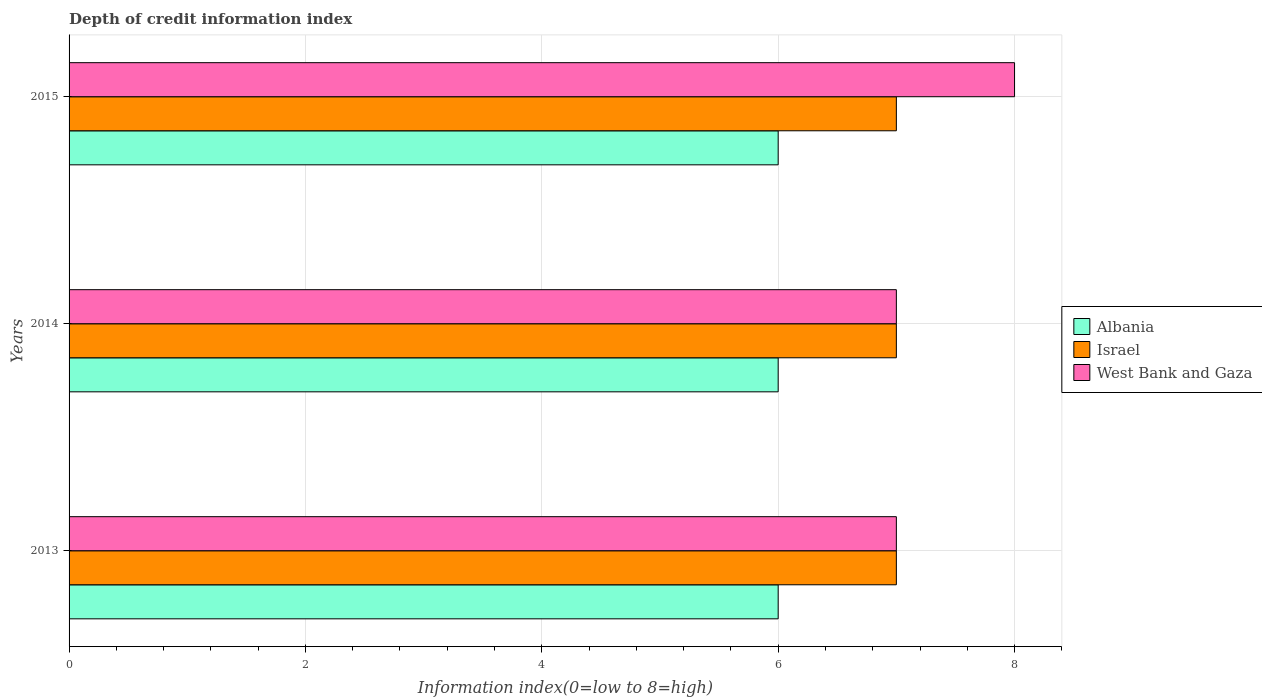How many groups of bars are there?
Provide a succinct answer. 3. Are the number of bars on each tick of the Y-axis equal?
Your answer should be very brief. Yes. How many bars are there on the 2nd tick from the top?
Offer a terse response. 3. How many bars are there on the 3rd tick from the bottom?
Provide a short and direct response. 3. What is the label of the 3rd group of bars from the top?
Ensure brevity in your answer.  2013. In how many cases, is the number of bars for a given year not equal to the number of legend labels?
Your answer should be compact. 0. What is the information index in West Bank and Gaza in 2013?
Ensure brevity in your answer.  7. Across all years, what is the minimum information index in Israel?
Ensure brevity in your answer.  7. In which year was the information index in West Bank and Gaza maximum?
Provide a short and direct response. 2015. In which year was the information index in West Bank and Gaza minimum?
Provide a short and direct response. 2013. What is the total information index in Israel in the graph?
Give a very brief answer. 21. What is the difference between the information index in Israel in 2013 and that in 2014?
Your answer should be very brief. 0. What is the difference between the information index in Israel in 2014 and the information index in West Bank and Gaza in 2015?
Offer a very short reply. -1. In the year 2015, what is the difference between the information index in Albania and information index in Israel?
Offer a terse response. -1. In how many years, is the information index in Israel greater than 7.2 ?
Offer a very short reply. 0. Is the information index in Israel in 2013 less than that in 2015?
Give a very brief answer. No. What is the difference between the highest and the second highest information index in West Bank and Gaza?
Give a very brief answer. 1. What is the difference between the highest and the lowest information index in West Bank and Gaza?
Your response must be concise. 1. Is the sum of the information index in Albania in 2013 and 2014 greater than the maximum information index in Israel across all years?
Your answer should be compact. Yes. What does the 1st bar from the top in 2014 represents?
Ensure brevity in your answer.  West Bank and Gaza. Are all the bars in the graph horizontal?
Keep it short and to the point. Yes. How many years are there in the graph?
Offer a very short reply. 3. What is the difference between two consecutive major ticks on the X-axis?
Ensure brevity in your answer.  2. Does the graph contain grids?
Your response must be concise. Yes. How are the legend labels stacked?
Provide a succinct answer. Vertical. What is the title of the graph?
Your response must be concise. Depth of credit information index. Does "Croatia" appear as one of the legend labels in the graph?
Offer a terse response. No. What is the label or title of the X-axis?
Your answer should be compact. Information index(0=low to 8=high). What is the label or title of the Y-axis?
Offer a very short reply. Years. What is the Information index(0=low to 8=high) of Albania in 2013?
Your answer should be very brief. 6. What is the Information index(0=low to 8=high) in Albania in 2014?
Ensure brevity in your answer.  6. What is the Information index(0=low to 8=high) of Israel in 2014?
Offer a terse response. 7. What is the Information index(0=low to 8=high) of Albania in 2015?
Make the answer very short. 6. What is the Information index(0=low to 8=high) of West Bank and Gaza in 2015?
Make the answer very short. 8. Across all years, what is the minimum Information index(0=low to 8=high) of West Bank and Gaza?
Offer a very short reply. 7. What is the total Information index(0=low to 8=high) in Israel in the graph?
Your answer should be very brief. 21. What is the difference between the Information index(0=low to 8=high) of Israel in 2013 and that in 2014?
Provide a succinct answer. 0. What is the difference between the Information index(0=low to 8=high) in West Bank and Gaza in 2013 and that in 2014?
Keep it short and to the point. 0. What is the difference between the Information index(0=low to 8=high) of West Bank and Gaza in 2013 and that in 2015?
Your answer should be compact. -1. What is the difference between the Information index(0=low to 8=high) of Albania in 2013 and the Information index(0=low to 8=high) of Israel in 2014?
Provide a succinct answer. -1. What is the difference between the Information index(0=low to 8=high) in Albania in 2013 and the Information index(0=low to 8=high) in West Bank and Gaza in 2014?
Your response must be concise. -1. What is the difference between the Information index(0=low to 8=high) of Albania in 2014 and the Information index(0=low to 8=high) of Israel in 2015?
Offer a very short reply. -1. What is the difference between the Information index(0=low to 8=high) of Israel in 2014 and the Information index(0=low to 8=high) of West Bank and Gaza in 2015?
Your answer should be very brief. -1. What is the average Information index(0=low to 8=high) of West Bank and Gaza per year?
Keep it short and to the point. 7.33. In the year 2013, what is the difference between the Information index(0=low to 8=high) of Albania and Information index(0=low to 8=high) of Israel?
Offer a terse response. -1. In the year 2013, what is the difference between the Information index(0=low to 8=high) of Albania and Information index(0=low to 8=high) of West Bank and Gaza?
Ensure brevity in your answer.  -1. In the year 2013, what is the difference between the Information index(0=low to 8=high) in Israel and Information index(0=low to 8=high) in West Bank and Gaza?
Offer a terse response. 0. In the year 2014, what is the difference between the Information index(0=low to 8=high) in Albania and Information index(0=low to 8=high) in West Bank and Gaza?
Offer a terse response. -1. In the year 2015, what is the difference between the Information index(0=low to 8=high) in Israel and Information index(0=low to 8=high) in West Bank and Gaza?
Provide a succinct answer. -1. What is the ratio of the Information index(0=low to 8=high) of Albania in 2013 to that in 2014?
Your answer should be compact. 1. What is the ratio of the Information index(0=low to 8=high) of West Bank and Gaza in 2013 to that in 2014?
Provide a succinct answer. 1. What is the difference between the highest and the second highest Information index(0=low to 8=high) of Israel?
Offer a terse response. 0. What is the difference between the highest and the second highest Information index(0=low to 8=high) in West Bank and Gaza?
Offer a very short reply. 1. What is the difference between the highest and the lowest Information index(0=low to 8=high) of Albania?
Keep it short and to the point. 0. What is the difference between the highest and the lowest Information index(0=low to 8=high) in Israel?
Provide a short and direct response. 0. 